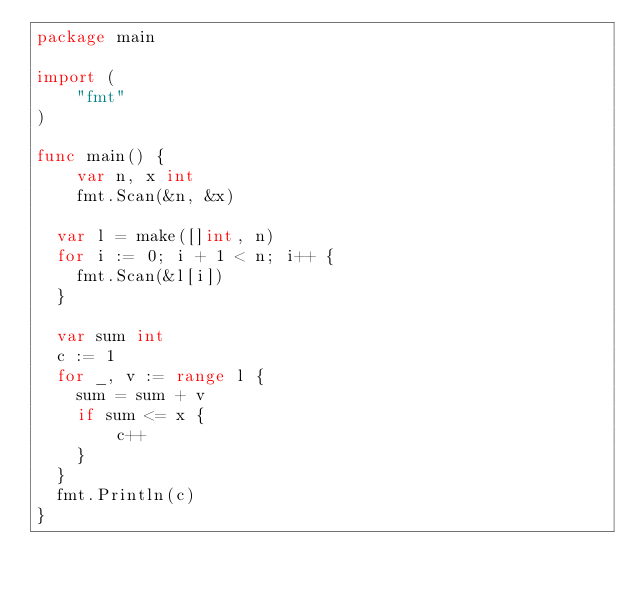Convert code to text. <code><loc_0><loc_0><loc_500><loc_500><_Go_>package main
 
import (
	"fmt"
)
 
func main() {
	var n, x int
	fmt.Scan(&n, &x)
 
  var l = make([]int, n)
  for i := 0; i + 1 < n; i++ {
    fmt.Scan(&l[i])
  }
  
  var sum int
  c := 1
  for _, v := range l {
    sum = sum + v
    if sum <= x {
	    c++
    }
  }
  fmt.Println(c)
}</code> 